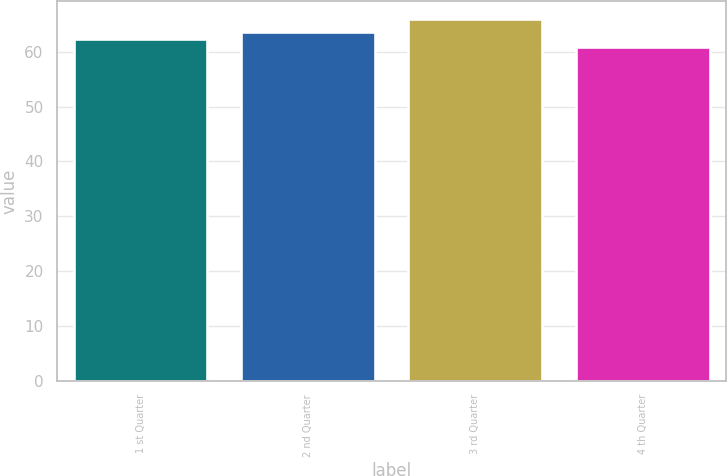Convert chart to OTSL. <chart><loc_0><loc_0><loc_500><loc_500><bar_chart><fcel>1 st Quarter<fcel>2 nd Quarter<fcel>3 rd Quarter<fcel>4 th Quarter<nl><fcel>62.26<fcel>63.64<fcel>65.98<fcel>60.83<nl></chart> 